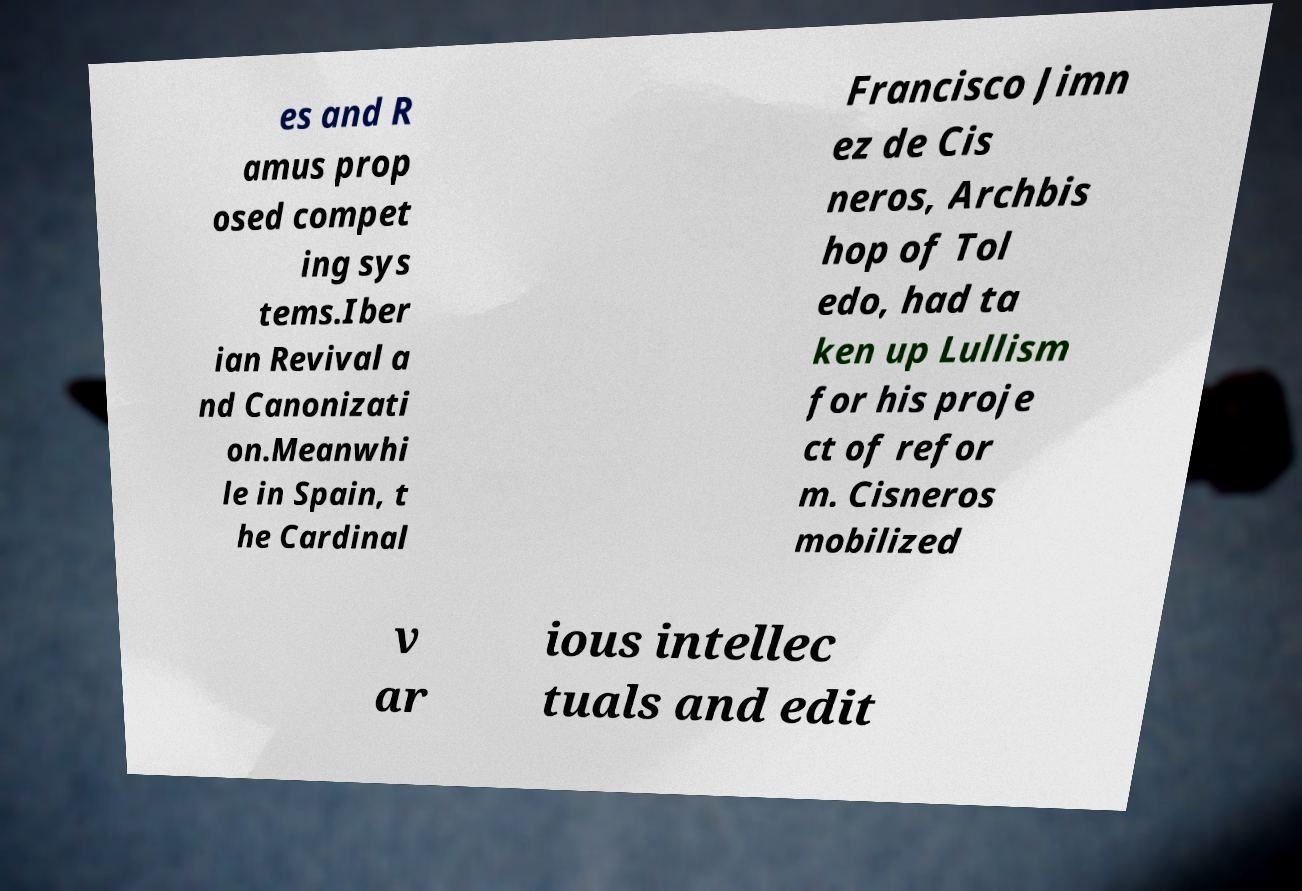What messages or text are displayed in this image? I need them in a readable, typed format. es and R amus prop osed compet ing sys tems.Iber ian Revival a nd Canonizati on.Meanwhi le in Spain, t he Cardinal Francisco Jimn ez de Cis neros, Archbis hop of Tol edo, had ta ken up Lullism for his proje ct of refor m. Cisneros mobilized v ar ious intellec tuals and edit 